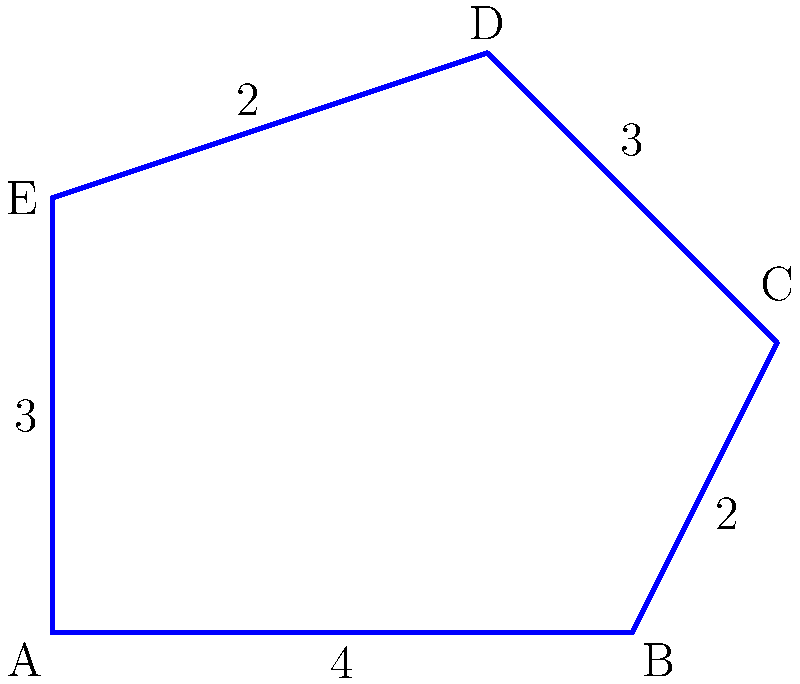In your app's user interface, you've designed a polygon-shaped "close app" button. The button's shape is shown in the diagram above, with side lengths measured in centimeters. Calculate the perimeter of this button. To find the perimeter of the polygon, we need to sum up the lengths of all sides:

1. Side AB: $4$ cm
2. Side BC: $2$ cm
3. Side CD: $3$ cm
4. Side DE: $2$ cm
5. Side EA: $3$ cm

Now, let's add all these lengths:

$$\text{Perimeter} = 4 + 2 + 3 + 2 + 3 = 14 \text{ cm}$$

Therefore, the perimeter of the polygon-shaped "close app" button is 14 cm.
Answer: $14 \text{ cm}$ 